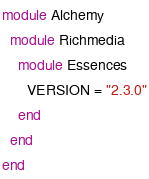Convert code to text. <code><loc_0><loc_0><loc_500><loc_500><_Ruby_>module Alchemy
  module Richmedia
    module Essences
      VERSION = "2.3.0"
    end
  end
end
</code> 